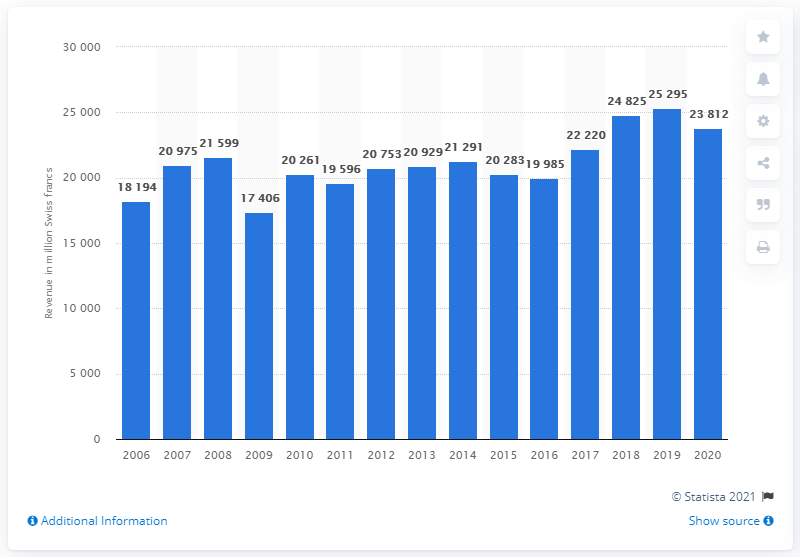Identify some key points in this picture. In the year 2020, Kuehne + Nagel's worldwide revenue came to an end. Kuehne + Nagel's worldwide revenue in Swiss francs in the fiscal year of 2020 was approximately 23,812. In 2006, Kuehne + Nagel reported its worldwide revenue for the first time. 